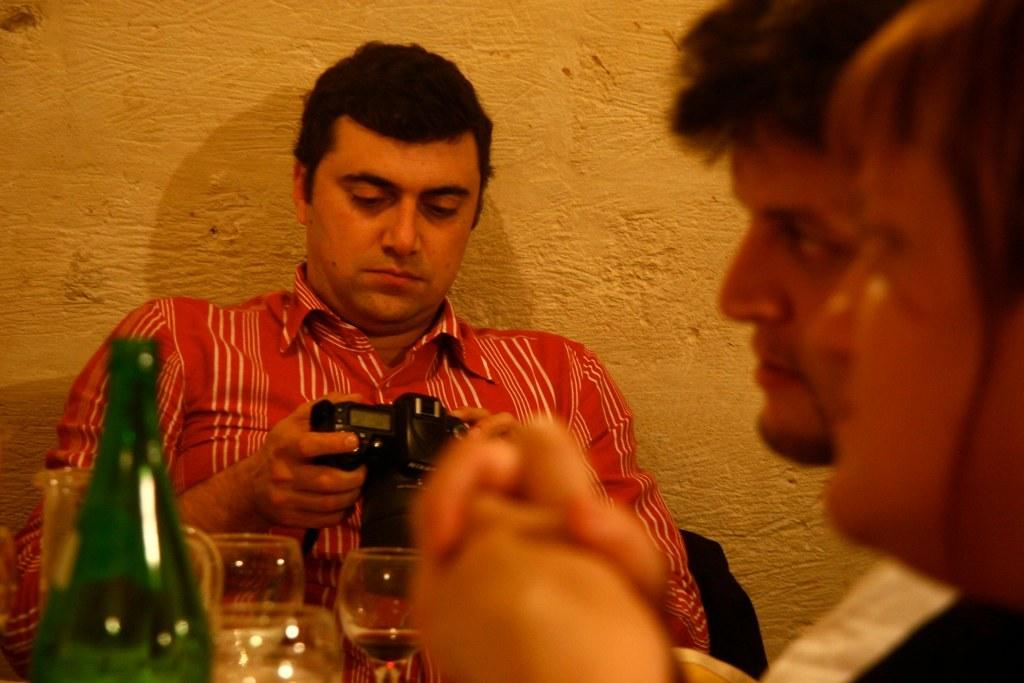How many men are in the image? There are three men in the image. What is one of the men doing in the image? One of the men is holding a camera. Can you describe the appearance of the man holding the camera? The man holding the camera is wearing a red shirt. What other objects can be seen in the image? There are glasses and a bottle visible in the image. How many sheep are visible in the image? There are no sheep present in the image. What type of owl can be seen perched on the man's shoulder in the image? There is no owl present in the image. 